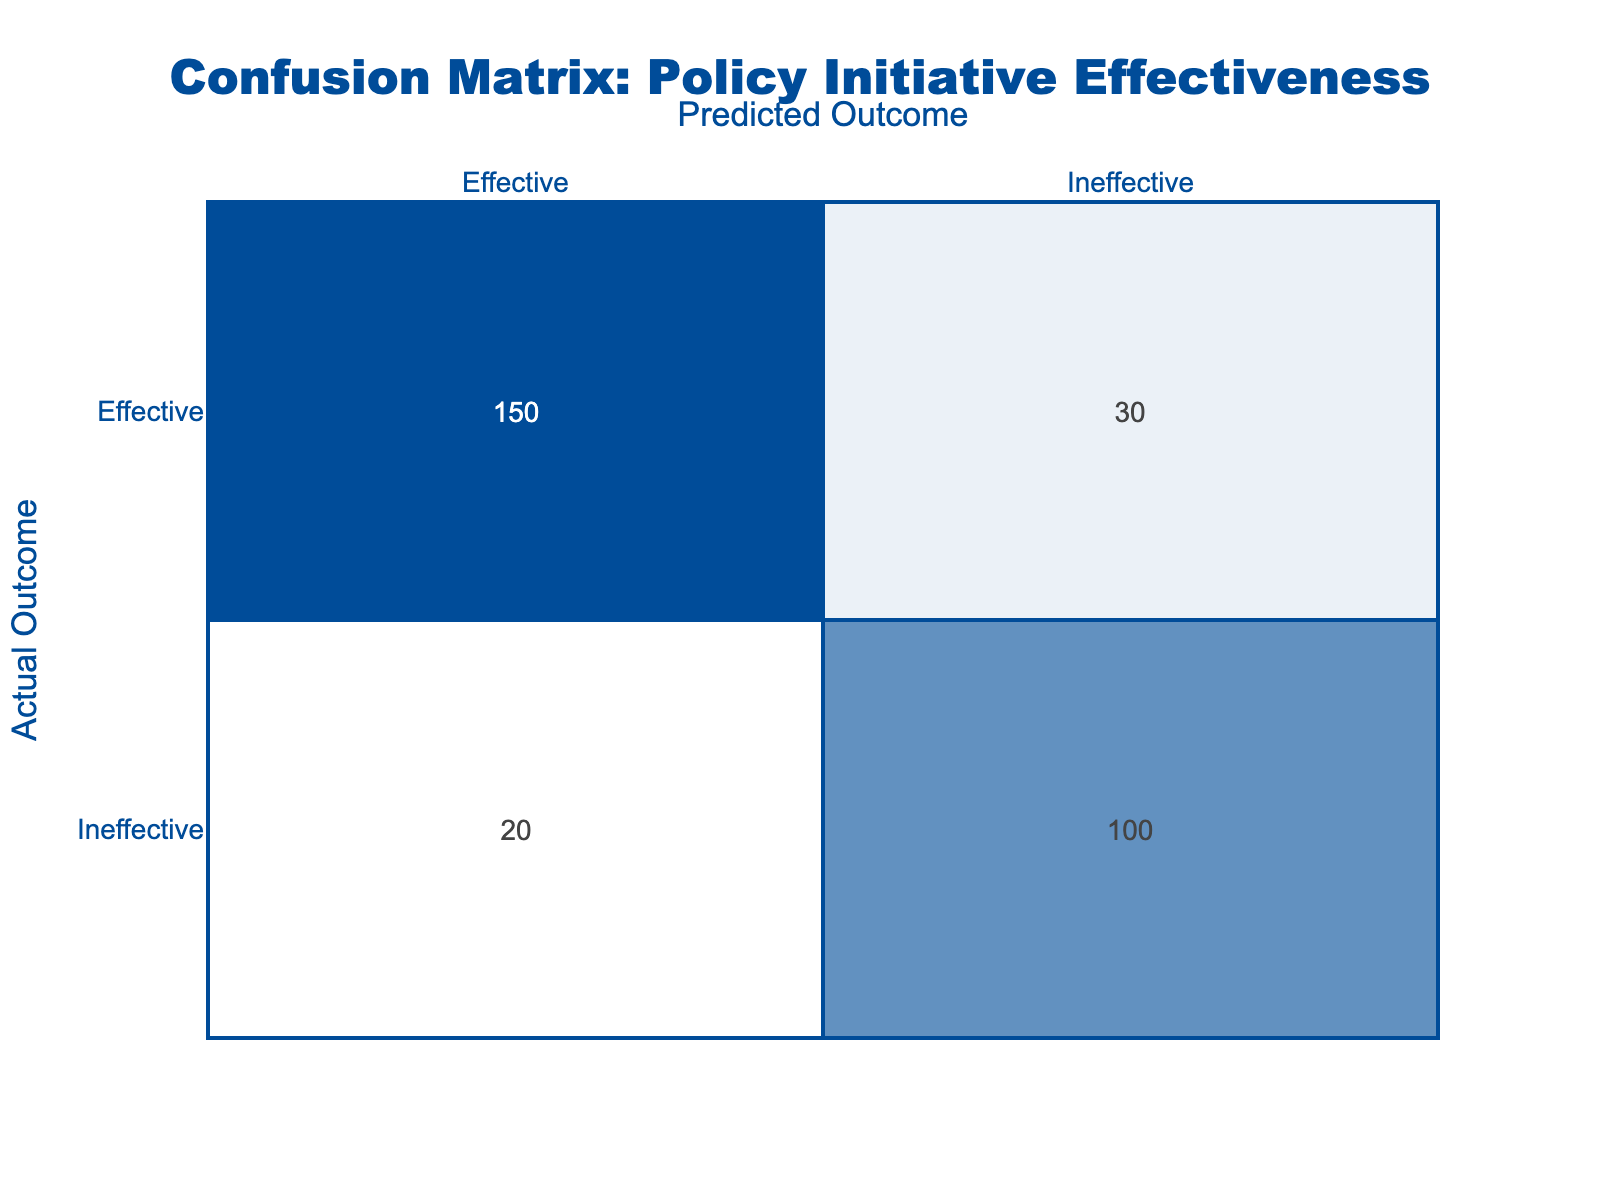What is the count of instances where the actual outcome was effective and the predicted outcome was ineffective? In the confusion matrix, we look at the row labeled "Effective" under the column labeled "Ineffective." The count displayed in this cell is 30.
Answer: 30 What is the total count of predicted outcomes for both effective and ineffective actual outcomes? To find the total count of predicted outcomes, we sum all the values in the matrix. That is 150 + 30 + 20 + 100 = 300.
Answer: 300 What percentage of the total instances were correctly predicted as effective? We first find the correctly predicted effective count, which is 150. The total count is 300. The percentage is calculated as (150 / 300) * 100 = 50%.
Answer: 50% Is the number of instances predicted as ineffective greater than those predicted as effective? We sum the counts of the "Ineffective" predicted column: 20 (effective predicted but actually ineffective) + 100 (ineffective predicted and actually ineffective) = 120. The effective predicted column has 150 + 30 = 180. Since 120 is less than 180, the answer is no.
Answer: No What is the combined count of all instances where the actual outcome was ineffective? We add the counts from both the "Ineffective" rows: 20 (effective predicted but actually ineffective) + 100 (ineffective predicted and actually ineffective) equals a total of 120.
Answer: 120 If we were to calculate the accuracy of the predictions, what would it be? Accuracy is calculated by taking the count of true positives and true negatives divided by the total instances. True positives: 150, true negatives: 100. Thus, accuracy is (150 + 100) / 300 = 250 / 300 = 0.8333, or approximately 83.33%.
Answer: 83.33% What is the difference between the count of true negatives and false negatives? True negatives is the count of ineffective predicted and actually ineffective, which is 100. False negatives is the count of effective predicted but actually ineffective, which is 30. Thus, the difference is 100 - 30 = 70.
Answer: 70 How many instances were predicted as effective but were actually ineffective? This can be found in the confusion matrix by looking at the "Effective" row and "Ineffective" column, which shows 20.
Answer: 20 What is the ratio of effective predictions to ineffective predictions? Effective predictions total is 150 (effective predicted and actually effective) + 30 (predicted effective but actually ineffective) = 180. Ineffective predictions total is 100 + 20 = 120. The ratio is 180:120, which simplifies to 3:2.
Answer: 3:2 